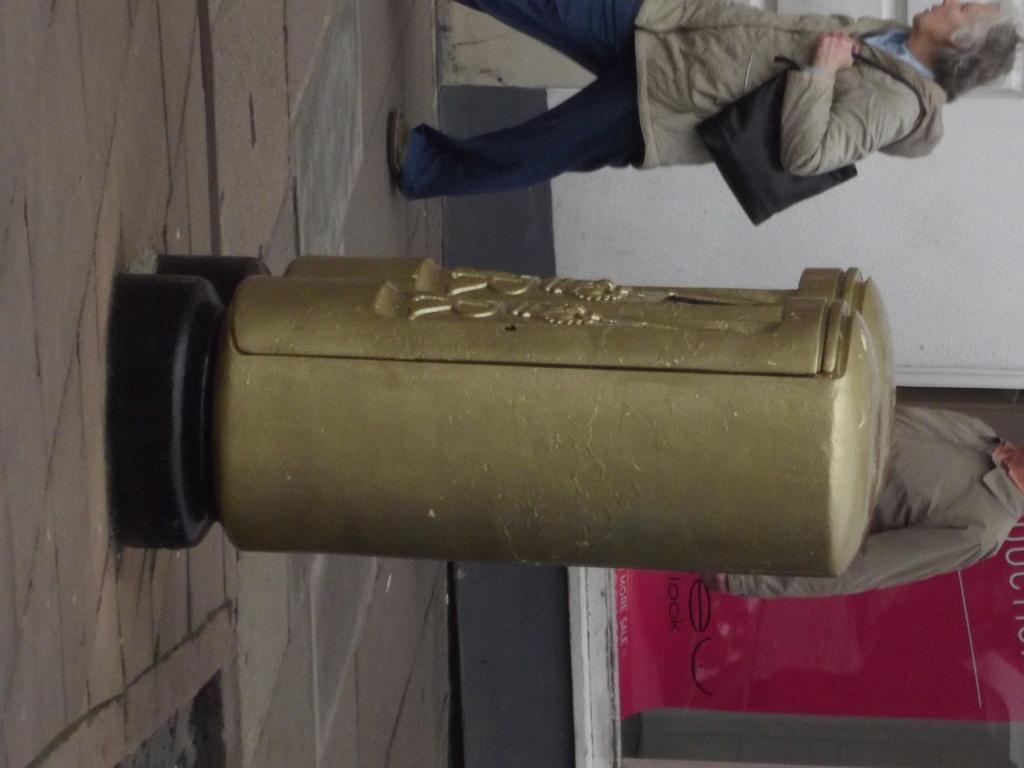Who is the main subject in the image? There is a lady in the image. Where is the lady located in the image? The lady is at the top side of the image. What objects can be seen in the center of the image? There are two golden color containers in the image. What type of receipt can be seen in the lady's hand in the image? There is no receipt present in the image; the lady's hands are not visible. 